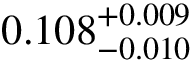<formula> <loc_0><loc_0><loc_500><loc_500>0 . 1 0 8 _ { - 0 . 0 1 0 } ^ { + 0 . 0 0 9 }</formula> 